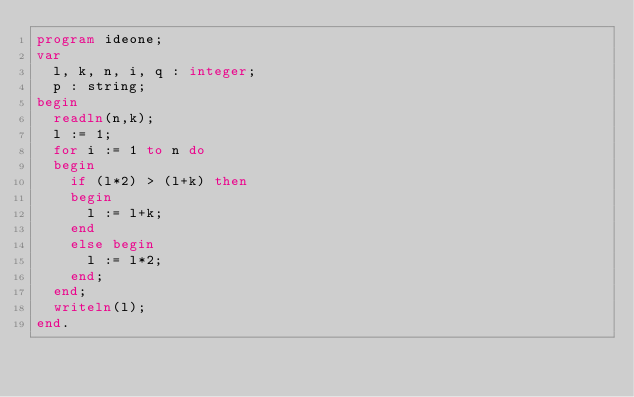<code> <loc_0><loc_0><loc_500><loc_500><_Pascal_>program ideone;
var
	l, k, n, i, q : integer;
	p : string;
begin
	readln(n,k);
	l := 1;
	for i := 1 to n do
	begin
		if (l*2) > (l+k) then
		begin
			l := l+k;
		end
		else begin
			l := l*2;
		end;
	end;
	writeln(l);
end.</code> 